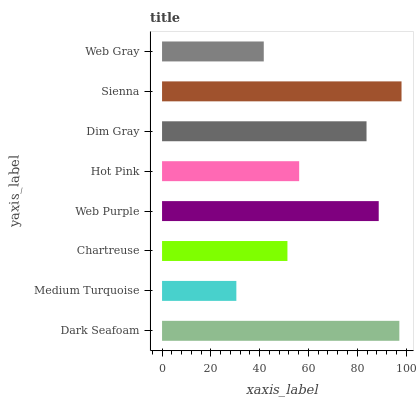Is Medium Turquoise the minimum?
Answer yes or no. Yes. Is Sienna the maximum?
Answer yes or no. Yes. Is Chartreuse the minimum?
Answer yes or no. No. Is Chartreuse the maximum?
Answer yes or no. No. Is Chartreuse greater than Medium Turquoise?
Answer yes or no. Yes. Is Medium Turquoise less than Chartreuse?
Answer yes or no. Yes. Is Medium Turquoise greater than Chartreuse?
Answer yes or no. No. Is Chartreuse less than Medium Turquoise?
Answer yes or no. No. Is Dim Gray the high median?
Answer yes or no. Yes. Is Hot Pink the low median?
Answer yes or no. Yes. Is Medium Turquoise the high median?
Answer yes or no. No. Is Web Purple the low median?
Answer yes or no. No. 